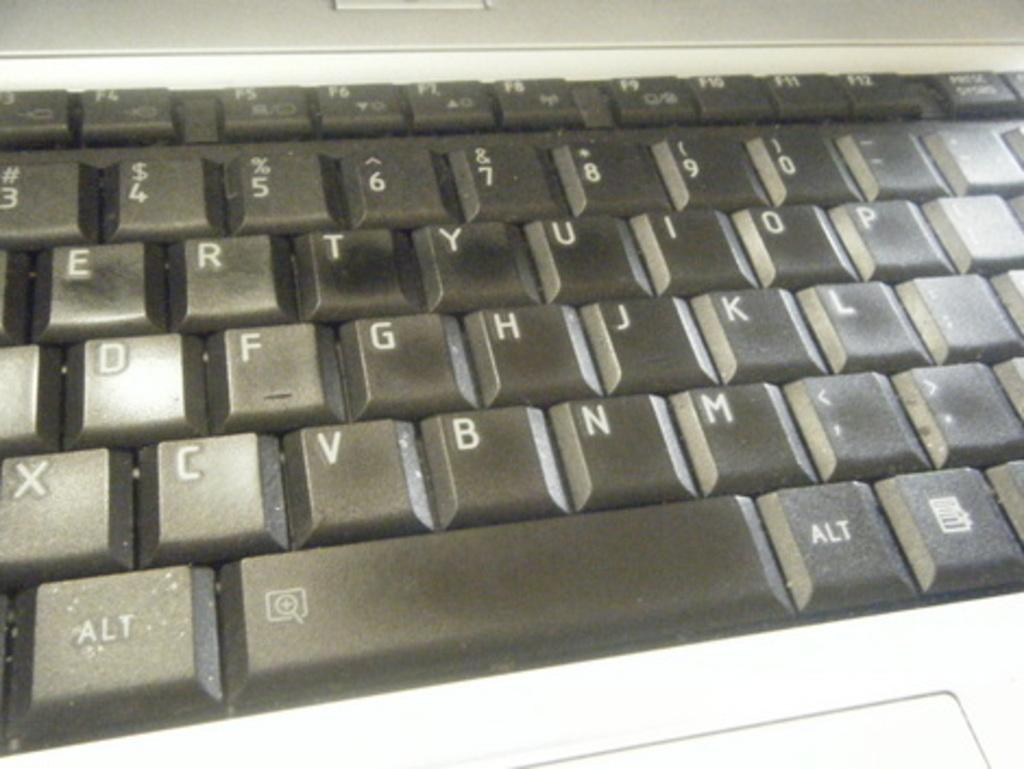<image>
Describe the image concisely. White and black keyboard keys with "ALT" on the bottom left. 